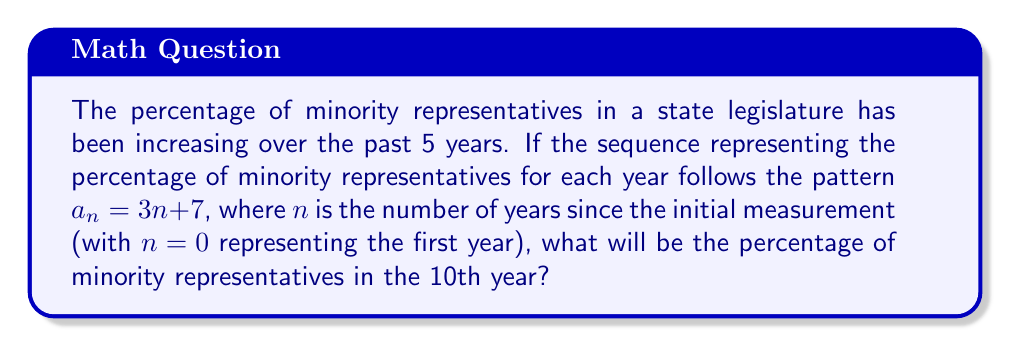Could you help me with this problem? To solve this problem, we need to follow these steps:

1) We are given the sequence $a_n = 3n + 7$, where $a_n$ represents the percentage of minority representatives and $n$ represents the number of years since the initial measurement.

2) We need to find the value for the 10th year, which means we need to calculate $a_9$ (since $n = 0$ represents the first year, $n = 9$ represents the 10th year).

3) Let's substitute $n = 9$ into our equation:

   $a_9 = 3(9) + 7$

4) Now, let's solve this equation:
   
   $a_9 = 27 + 7 = 34$

5) Therefore, in the 10th year, the percentage of minority representatives will be 34%.

This sequence shows a steady increase in minority representation, which aligns with the goal of fighting for equality in political representation.
Answer: 34% 